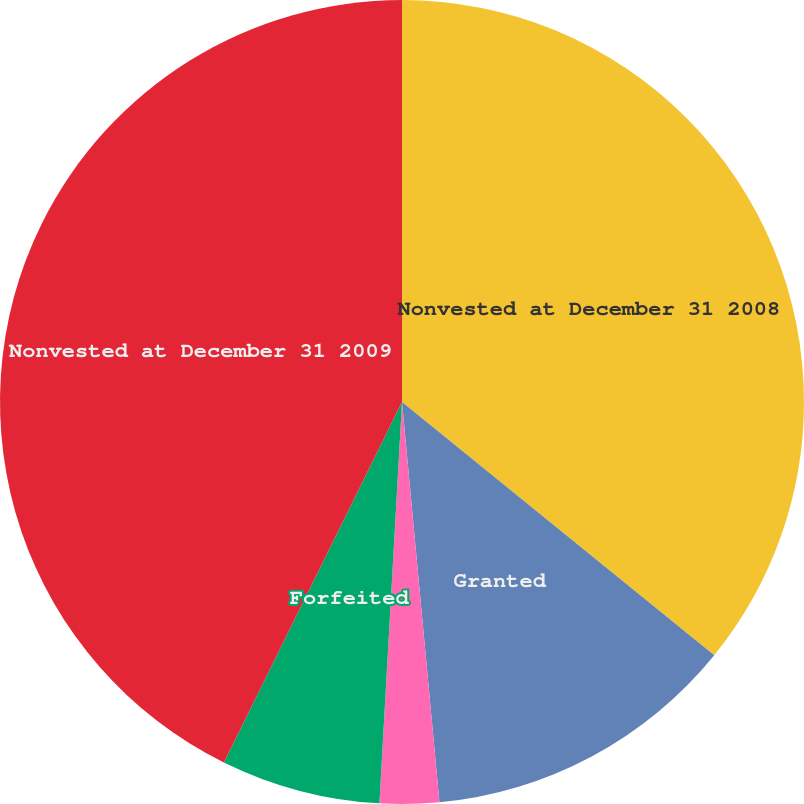Convert chart to OTSL. <chart><loc_0><loc_0><loc_500><loc_500><pie_chart><fcel>Nonvested at December 31 2008<fcel>Granted<fcel>Vested<fcel>Forfeited<fcel>Nonvested at December 31 2009<nl><fcel>35.84%<fcel>12.67%<fcel>2.38%<fcel>6.41%<fcel>42.69%<nl></chart> 